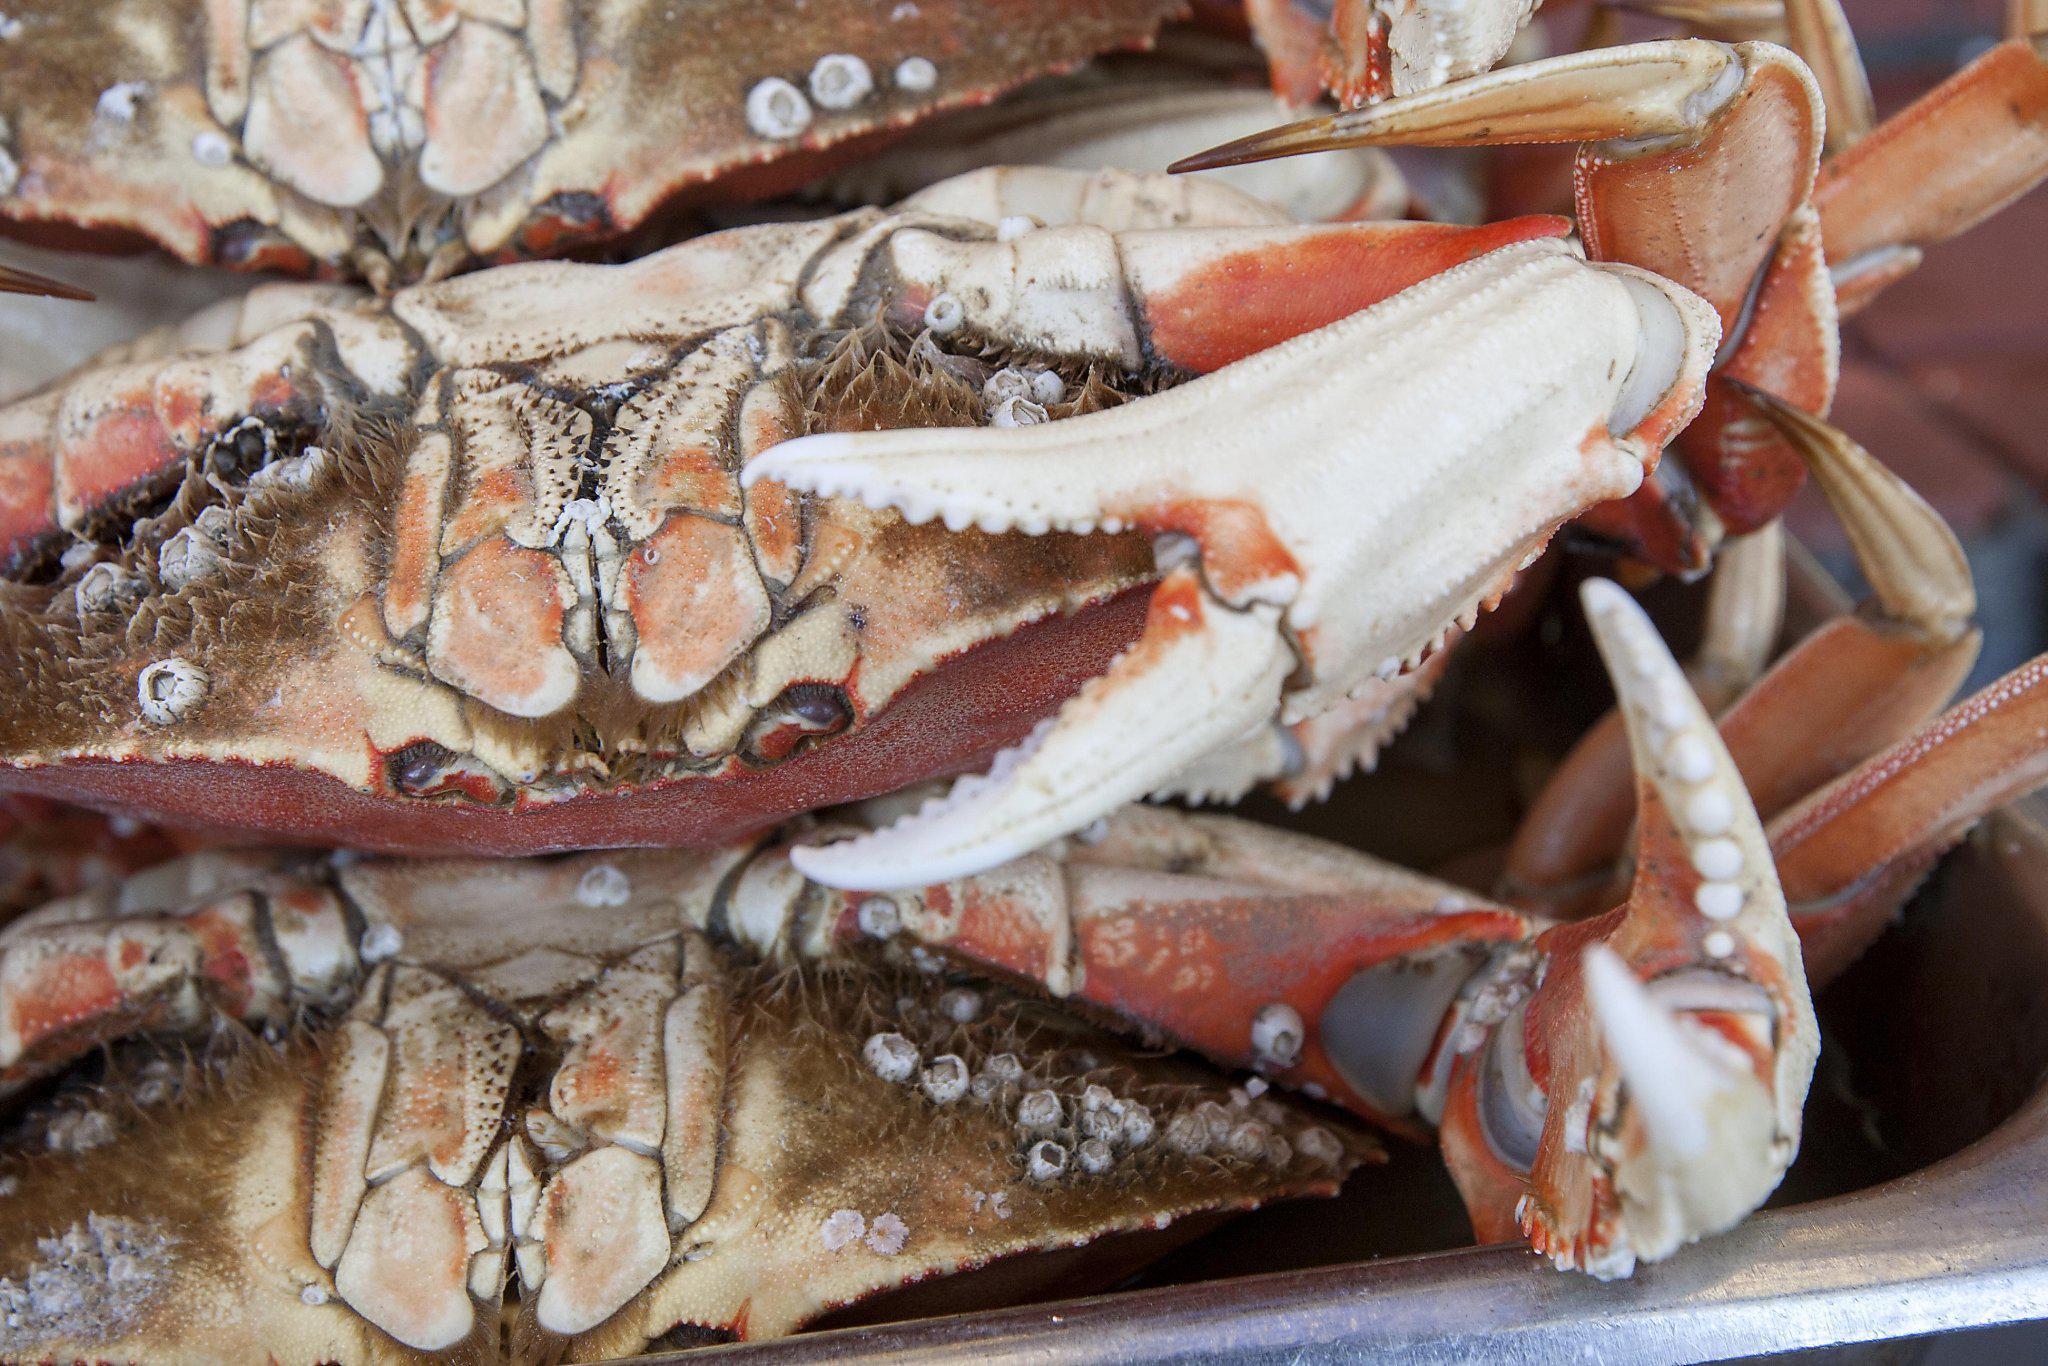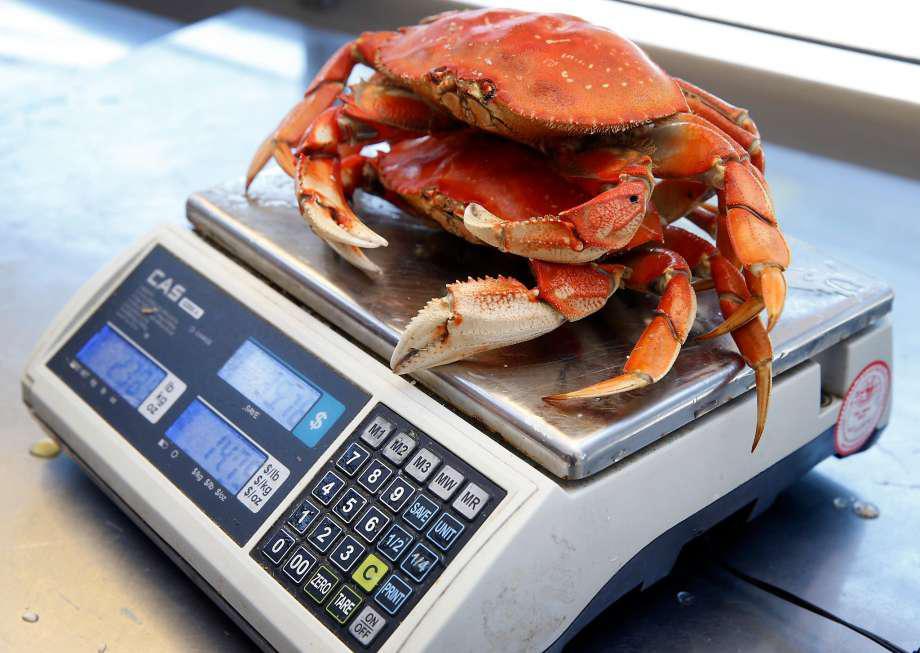The first image is the image on the left, the second image is the image on the right. Given the left and right images, does the statement "The crabs in one of the images are being weighed with a scale." hold true? Answer yes or no. Yes. The first image is the image on the left, the second image is the image on the right. Given the left and right images, does the statement "One image shows a pile of shell-side up crabs without a container, and the other image shows a mass of crabs in a round container." hold true? Answer yes or no. No. 